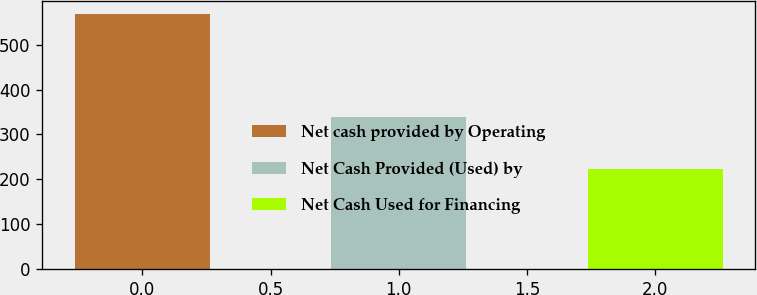Convert chart. <chart><loc_0><loc_0><loc_500><loc_500><bar_chart><fcel>Net cash provided by Operating<fcel>Net Cash Provided (Used) by<fcel>Net Cash Used for Financing<nl><fcel>569.6<fcel>338<fcel>223.7<nl></chart> 